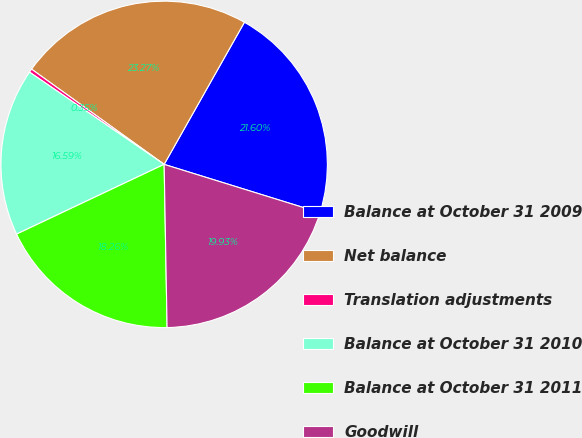Convert chart. <chart><loc_0><loc_0><loc_500><loc_500><pie_chart><fcel>Balance at October 31 2009<fcel>Net balance<fcel>Translation adjustments<fcel>Balance at October 31 2010<fcel>Balance at October 31 2011<fcel>Goodwill<nl><fcel>21.6%<fcel>23.27%<fcel>0.35%<fcel>16.59%<fcel>18.26%<fcel>19.93%<nl></chart> 